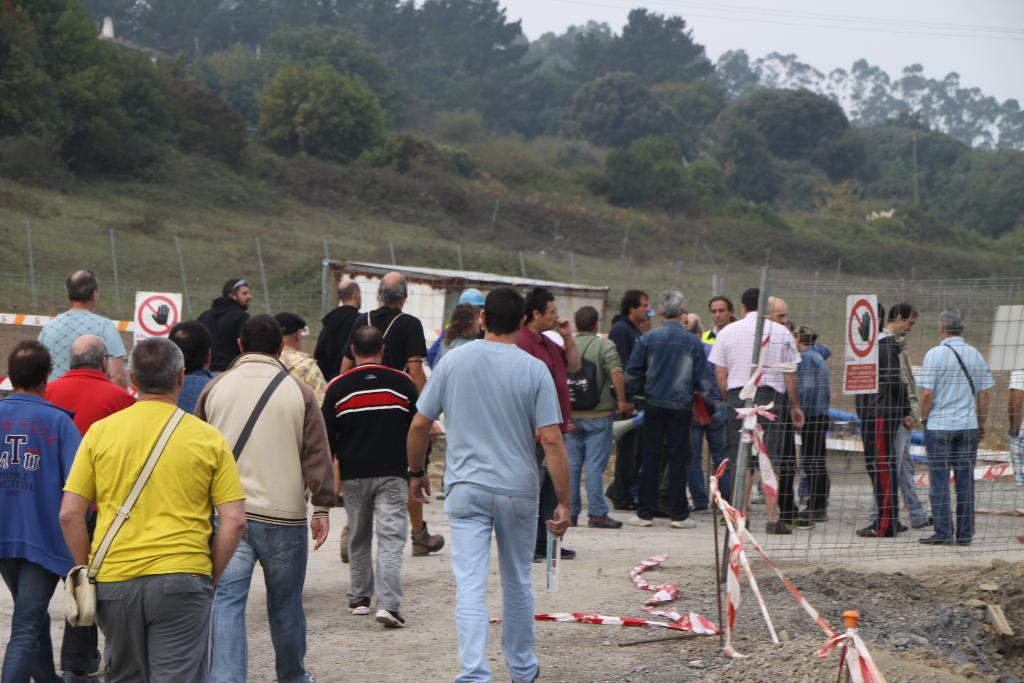What is the main subject of the image? The main subject of the image is people. Where are the people located in the image? The people are in the center of the image. What is in front of the people? There is a boundary in front of the people. What can be seen at the top side of the image? There are trees at the top side of the image. Can you see any kettles boiling water in the image? There are no kettles present in the image. 